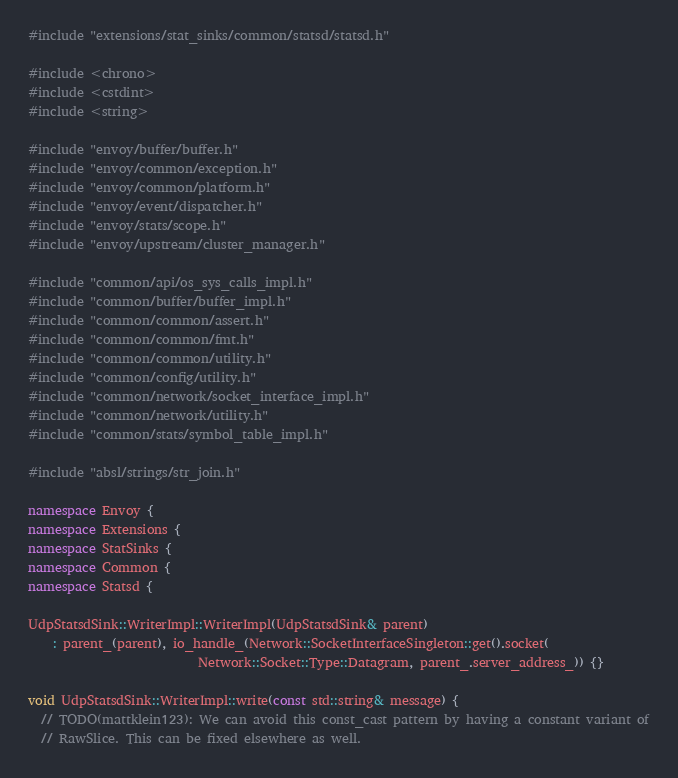<code> <loc_0><loc_0><loc_500><loc_500><_C++_>#include "extensions/stat_sinks/common/statsd/statsd.h"

#include <chrono>
#include <cstdint>
#include <string>

#include "envoy/buffer/buffer.h"
#include "envoy/common/exception.h"
#include "envoy/common/platform.h"
#include "envoy/event/dispatcher.h"
#include "envoy/stats/scope.h"
#include "envoy/upstream/cluster_manager.h"

#include "common/api/os_sys_calls_impl.h"
#include "common/buffer/buffer_impl.h"
#include "common/common/assert.h"
#include "common/common/fmt.h"
#include "common/common/utility.h"
#include "common/config/utility.h"
#include "common/network/socket_interface_impl.h"
#include "common/network/utility.h"
#include "common/stats/symbol_table_impl.h"

#include "absl/strings/str_join.h"

namespace Envoy {
namespace Extensions {
namespace StatSinks {
namespace Common {
namespace Statsd {

UdpStatsdSink::WriterImpl::WriterImpl(UdpStatsdSink& parent)
    : parent_(parent), io_handle_(Network::SocketInterfaceSingleton::get().socket(
                           Network::Socket::Type::Datagram, parent_.server_address_)) {}

void UdpStatsdSink::WriterImpl::write(const std::string& message) {
  // TODO(mattklein123): We can avoid this const_cast pattern by having a constant variant of
  // RawSlice. This can be fixed elsewhere as well.</code> 